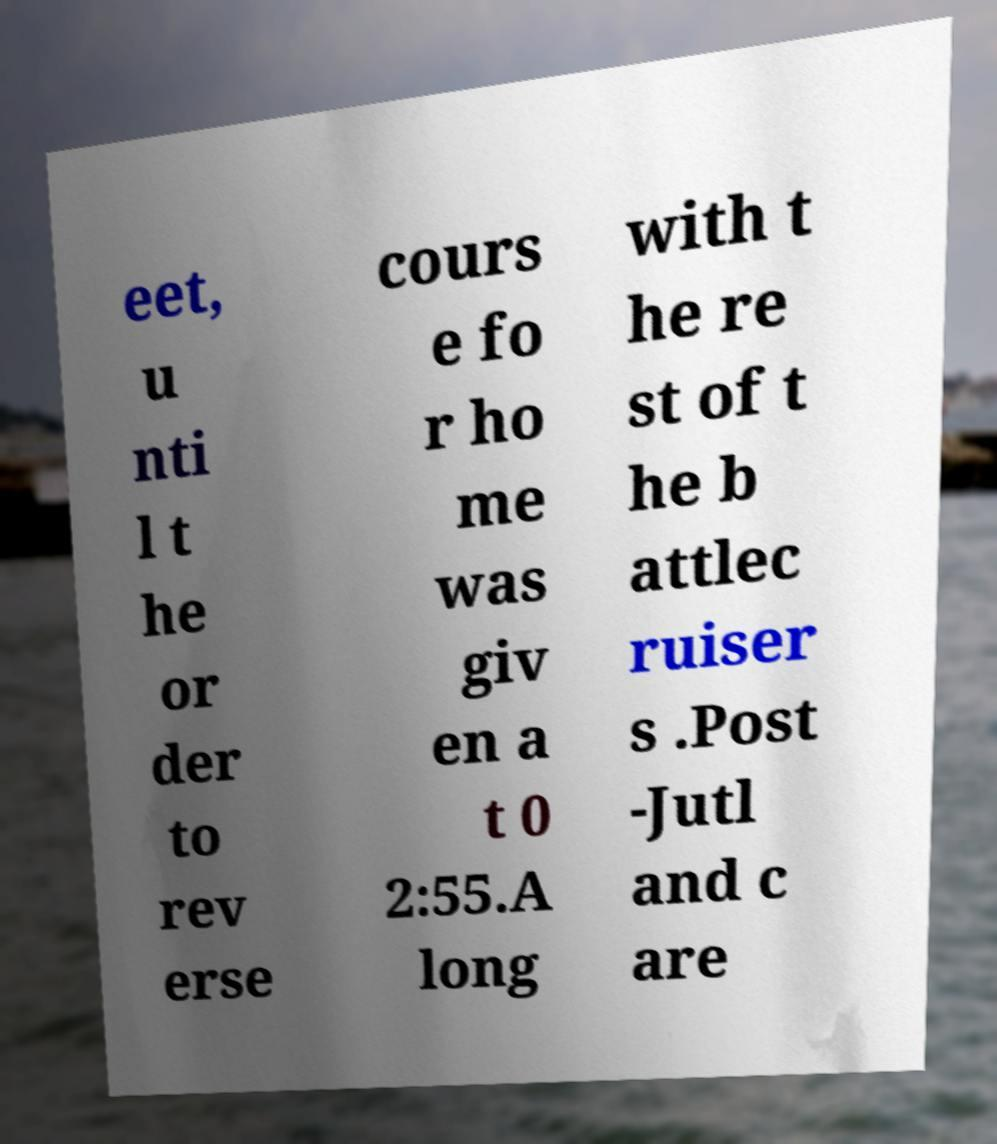Can you accurately transcribe the text from the provided image for me? eet, u nti l t he or der to rev erse cours e fo r ho me was giv en a t 0 2:55.A long with t he re st of t he b attlec ruiser s .Post -Jutl and c are 